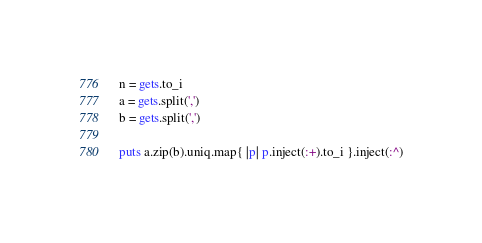Convert code to text. <code><loc_0><loc_0><loc_500><loc_500><_Ruby_>n = gets.to_i
a = gets.split(',')
b = gets.split(',')

puts a.zip(b).uniq.map{ |p| p.inject(:+).to_i }.inject(:^)</code> 